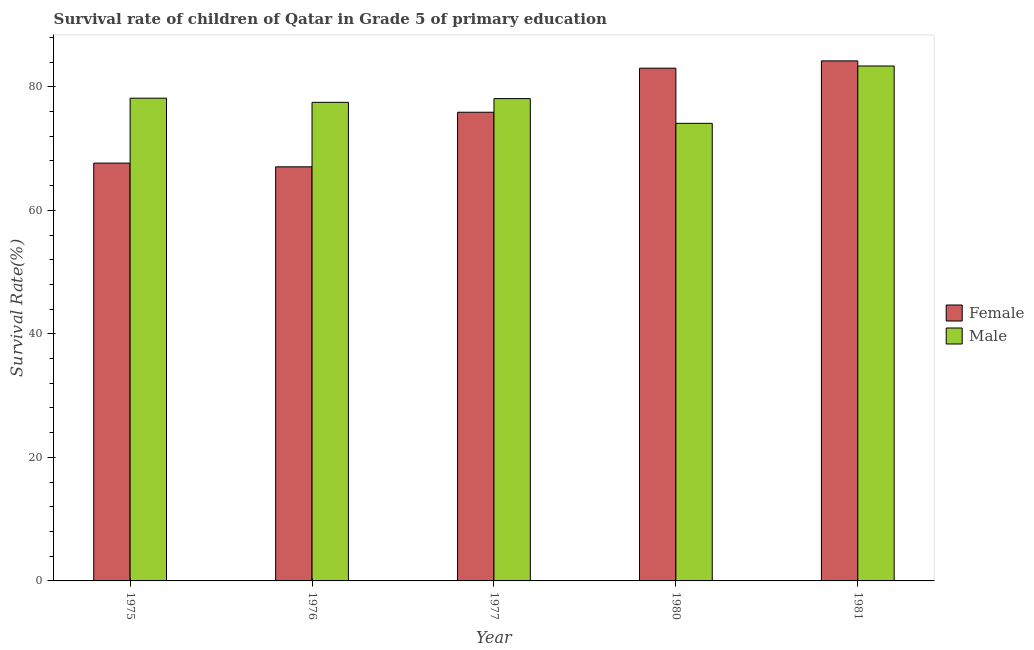How many groups of bars are there?
Provide a short and direct response. 5. Are the number of bars per tick equal to the number of legend labels?
Provide a short and direct response. Yes. Are the number of bars on each tick of the X-axis equal?
Your response must be concise. Yes. How many bars are there on the 5th tick from the left?
Ensure brevity in your answer.  2. How many bars are there on the 2nd tick from the right?
Ensure brevity in your answer.  2. What is the label of the 1st group of bars from the left?
Give a very brief answer. 1975. What is the survival rate of male students in primary education in 1975?
Ensure brevity in your answer.  78.16. Across all years, what is the maximum survival rate of male students in primary education?
Your response must be concise. 83.37. Across all years, what is the minimum survival rate of female students in primary education?
Keep it short and to the point. 67.05. In which year was the survival rate of female students in primary education minimum?
Ensure brevity in your answer.  1976. What is the total survival rate of male students in primary education in the graph?
Make the answer very short. 391.2. What is the difference between the survival rate of female students in primary education in 1977 and that in 1980?
Provide a short and direct response. -7.14. What is the difference between the survival rate of male students in primary education in 1980 and the survival rate of female students in primary education in 1981?
Give a very brief answer. -9.29. What is the average survival rate of male students in primary education per year?
Provide a succinct answer. 78.24. In the year 1980, what is the difference between the survival rate of male students in primary education and survival rate of female students in primary education?
Provide a short and direct response. 0. What is the ratio of the survival rate of male students in primary education in 1975 to that in 1977?
Your answer should be compact. 1. Is the survival rate of female students in primary education in 1975 less than that in 1976?
Offer a very short reply. No. What is the difference between the highest and the second highest survival rate of female students in primary education?
Your answer should be very brief. 1.18. What is the difference between the highest and the lowest survival rate of female students in primary education?
Your answer should be compact. 17.15. In how many years, is the survival rate of male students in primary education greater than the average survival rate of male students in primary education taken over all years?
Provide a succinct answer. 1. What does the 2nd bar from the right in 1980 represents?
Your answer should be very brief. Female. Does the graph contain grids?
Your response must be concise. No. Where does the legend appear in the graph?
Offer a very short reply. Center right. How are the legend labels stacked?
Offer a terse response. Vertical. What is the title of the graph?
Offer a terse response. Survival rate of children of Qatar in Grade 5 of primary education. Does "Time to import" appear as one of the legend labels in the graph?
Offer a terse response. No. What is the label or title of the Y-axis?
Give a very brief answer. Survival Rate(%). What is the Survival Rate(%) of Female in 1975?
Ensure brevity in your answer.  67.65. What is the Survival Rate(%) in Male in 1975?
Your answer should be very brief. 78.16. What is the Survival Rate(%) in Female in 1976?
Your response must be concise. 67.05. What is the Survival Rate(%) of Male in 1976?
Keep it short and to the point. 77.49. What is the Survival Rate(%) in Female in 1977?
Your answer should be compact. 75.88. What is the Survival Rate(%) in Male in 1977?
Provide a short and direct response. 78.09. What is the Survival Rate(%) of Female in 1980?
Your answer should be very brief. 83.02. What is the Survival Rate(%) of Male in 1980?
Keep it short and to the point. 74.08. What is the Survival Rate(%) of Female in 1981?
Provide a short and direct response. 84.2. What is the Survival Rate(%) of Male in 1981?
Offer a very short reply. 83.37. Across all years, what is the maximum Survival Rate(%) in Female?
Provide a short and direct response. 84.2. Across all years, what is the maximum Survival Rate(%) of Male?
Offer a terse response. 83.37. Across all years, what is the minimum Survival Rate(%) of Female?
Provide a succinct answer. 67.05. Across all years, what is the minimum Survival Rate(%) of Male?
Make the answer very short. 74.08. What is the total Survival Rate(%) of Female in the graph?
Provide a short and direct response. 377.81. What is the total Survival Rate(%) of Male in the graph?
Make the answer very short. 391.2. What is the difference between the Survival Rate(%) in Female in 1975 and that in 1976?
Make the answer very short. 0.6. What is the difference between the Survival Rate(%) of Male in 1975 and that in 1976?
Provide a succinct answer. 0.67. What is the difference between the Survival Rate(%) of Female in 1975 and that in 1977?
Offer a very short reply. -8.23. What is the difference between the Survival Rate(%) of Male in 1975 and that in 1977?
Your answer should be compact. 0.07. What is the difference between the Survival Rate(%) of Female in 1975 and that in 1980?
Your answer should be compact. -15.37. What is the difference between the Survival Rate(%) in Male in 1975 and that in 1980?
Make the answer very short. 4.08. What is the difference between the Survival Rate(%) of Female in 1975 and that in 1981?
Provide a succinct answer. -16.55. What is the difference between the Survival Rate(%) in Male in 1975 and that in 1981?
Your response must be concise. -5.21. What is the difference between the Survival Rate(%) in Female in 1976 and that in 1977?
Offer a very short reply. -8.84. What is the difference between the Survival Rate(%) of Male in 1976 and that in 1977?
Provide a short and direct response. -0.6. What is the difference between the Survival Rate(%) of Female in 1976 and that in 1980?
Keep it short and to the point. -15.97. What is the difference between the Survival Rate(%) in Male in 1976 and that in 1980?
Ensure brevity in your answer.  3.4. What is the difference between the Survival Rate(%) of Female in 1976 and that in 1981?
Provide a succinct answer. -17.15. What is the difference between the Survival Rate(%) of Male in 1976 and that in 1981?
Provide a short and direct response. -5.88. What is the difference between the Survival Rate(%) of Female in 1977 and that in 1980?
Keep it short and to the point. -7.14. What is the difference between the Survival Rate(%) in Male in 1977 and that in 1980?
Ensure brevity in your answer.  4.01. What is the difference between the Survival Rate(%) in Female in 1977 and that in 1981?
Your response must be concise. -8.32. What is the difference between the Survival Rate(%) in Male in 1977 and that in 1981?
Your response must be concise. -5.28. What is the difference between the Survival Rate(%) of Female in 1980 and that in 1981?
Offer a very short reply. -1.18. What is the difference between the Survival Rate(%) of Male in 1980 and that in 1981?
Ensure brevity in your answer.  -9.29. What is the difference between the Survival Rate(%) of Female in 1975 and the Survival Rate(%) of Male in 1976?
Offer a very short reply. -9.84. What is the difference between the Survival Rate(%) of Female in 1975 and the Survival Rate(%) of Male in 1977?
Make the answer very short. -10.44. What is the difference between the Survival Rate(%) of Female in 1975 and the Survival Rate(%) of Male in 1980?
Make the answer very short. -6.43. What is the difference between the Survival Rate(%) of Female in 1975 and the Survival Rate(%) of Male in 1981?
Ensure brevity in your answer.  -15.72. What is the difference between the Survival Rate(%) of Female in 1976 and the Survival Rate(%) of Male in 1977?
Provide a short and direct response. -11.04. What is the difference between the Survival Rate(%) in Female in 1976 and the Survival Rate(%) in Male in 1980?
Provide a succinct answer. -7.04. What is the difference between the Survival Rate(%) in Female in 1976 and the Survival Rate(%) in Male in 1981?
Offer a terse response. -16.32. What is the difference between the Survival Rate(%) in Female in 1977 and the Survival Rate(%) in Male in 1980?
Ensure brevity in your answer.  1.8. What is the difference between the Survival Rate(%) of Female in 1977 and the Survival Rate(%) of Male in 1981?
Offer a very short reply. -7.49. What is the difference between the Survival Rate(%) of Female in 1980 and the Survival Rate(%) of Male in 1981?
Your answer should be very brief. -0.35. What is the average Survival Rate(%) in Female per year?
Keep it short and to the point. 75.56. What is the average Survival Rate(%) in Male per year?
Give a very brief answer. 78.24. In the year 1975, what is the difference between the Survival Rate(%) in Female and Survival Rate(%) in Male?
Provide a short and direct response. -10.51. In the year 1976, what is the difference between the Survival Rate(%) in Female and Survival Rate(%) in Male?
Provide a short and direct response. -10.44. In the year 1977, what is the difference between the Survival Rate(%) in Female and Survival Rate(%) in Male?
Offer a terse response. -2.21. In the year 1980, what is the difference between the Survival Rate(%) in Female and Survival Rate(%) in Male?
Give a very brief answer. 8.94. In the year 1981, what is the difference between the Survival Rate(%) in Female and Survival Rate(%) in Male?
Make the answer very short. 0.83. What is the ratio of the Survival Rate(%) of Female in 1975 to that in 1976?
Your answer should be compact. 1.01. What is the ratio of the Survival Rate(%) in Male in 1975 to that in 1976?
Offer a very short reply. 1.01. What is the ratio of the Survival Rate(%) in Female in 1975 to that in 1977?
Offer a terse response. 0.89. What is the ratio of the Survival Rate(%) in Female in 1975 to that in 1980?
Ensure brevity in your answer.  0.81. What is the ratio of the Survival Rate(%) in Male in 1975 to that in 1980?
Offer a very short reply. 1.05. What is the ratio of the Survival Rate(%) in Female in 1975 to that in 1981?
Your answer should be very brief. 0.8. What is the ratio of the Survival Rate(%) in Female in 1976 to that in 1977?
Make the answer very short. 0.88. What is the ratio of the Survival Rate(%) in Male in 1976 to that in 1977?
Give a very brief answer. 0.99. What is the ratio of the Survival Rate(%) of Female in 1976 to that in 1980?
Ensure brevity in your answer.  0.81. What is the ratio of the Survival Rate(%) in Male in 1976 to that in 1980?
Make the answer very short. 1.05. What is the ratio of the Survival Rate(%) of Female in 1976 to that in 1981?
Keep it short and to the point. 0.8. What is the ratio of the Survival Rate(%) in Male in 1976 to that in 1981?
Provide a short and direct response. 0.93. What is the ratio of the Survival Rate(%) in Female in 1977 to that in 1980?
Give a very brief answer. 0.91. What is the ratio of the Survival Rate(%) of Male in 1977 to that in 1980?
Your answer should be very brief. 1.05. What is the ratio of the Survival Rate(%) in Female in 1977 to that in 1981?
Your answer should be compact. 0.9. What is the ratio of the Survival Rate(%) of Male in 1977 to that in 1981?
Your answer should be compact. 0.94. What is the ratio of the Survival Rate(%) in Male in 1980 to that in 1981?
Your answer should be compact. 0.89. What is the difference between the highest and the second highest Survival Rate(%) of Female?
Ensure brevity in your answer.  1.18. What is the difference between the highest and the second highest Survival Rate(%) of Male?
Your answer should be very brief. 5.21. What is the difference between the highest and the lowest Survival Rate(%) of Female?
Your answer should be very brief. 17.15. What is the difference between the highest and the lowest Survival Rate(%) in Male?
Your answer should be very brief. 9.29. 